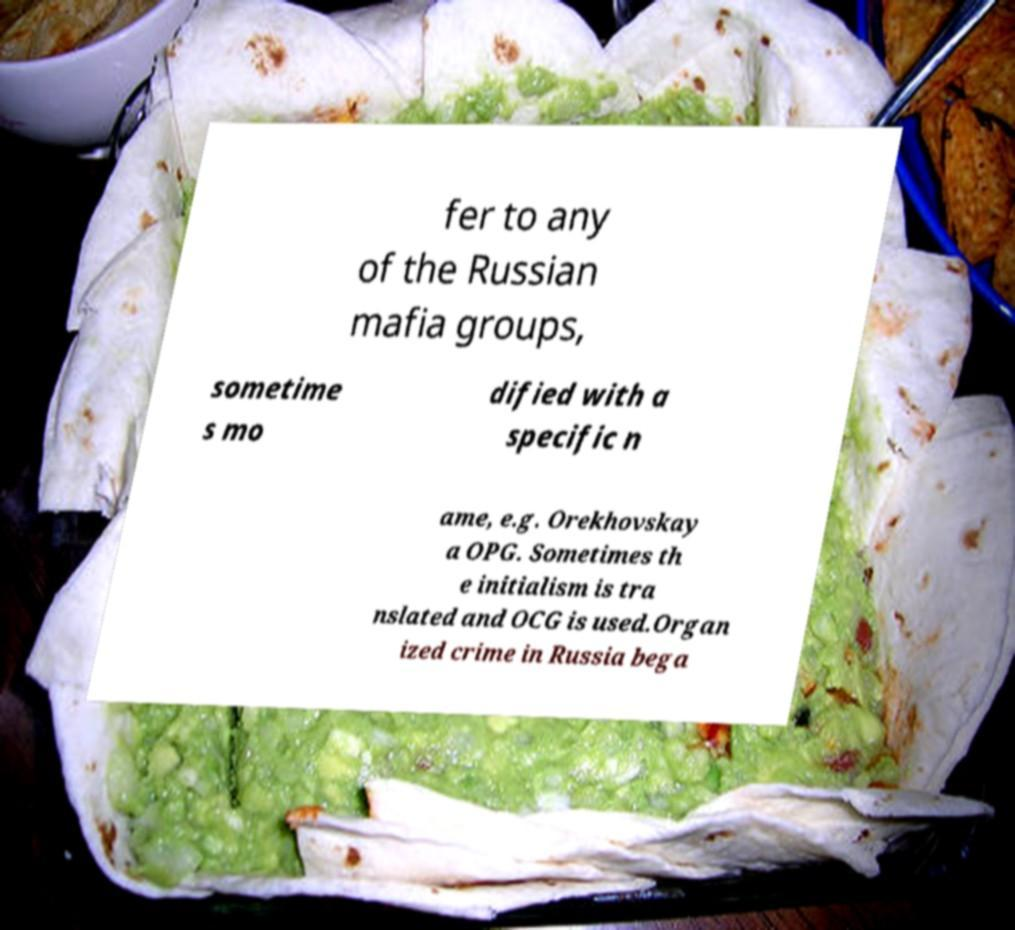Please read and relay the text visible in this image. What does it say? fer to any of the Russian mafia groups, sometime s mo dified with a specific n ame, e.g. Orekhovskay a OPG. Sometimes th e initialism is tra nslated and OCG is used.Organ ized crime in Russia bega 